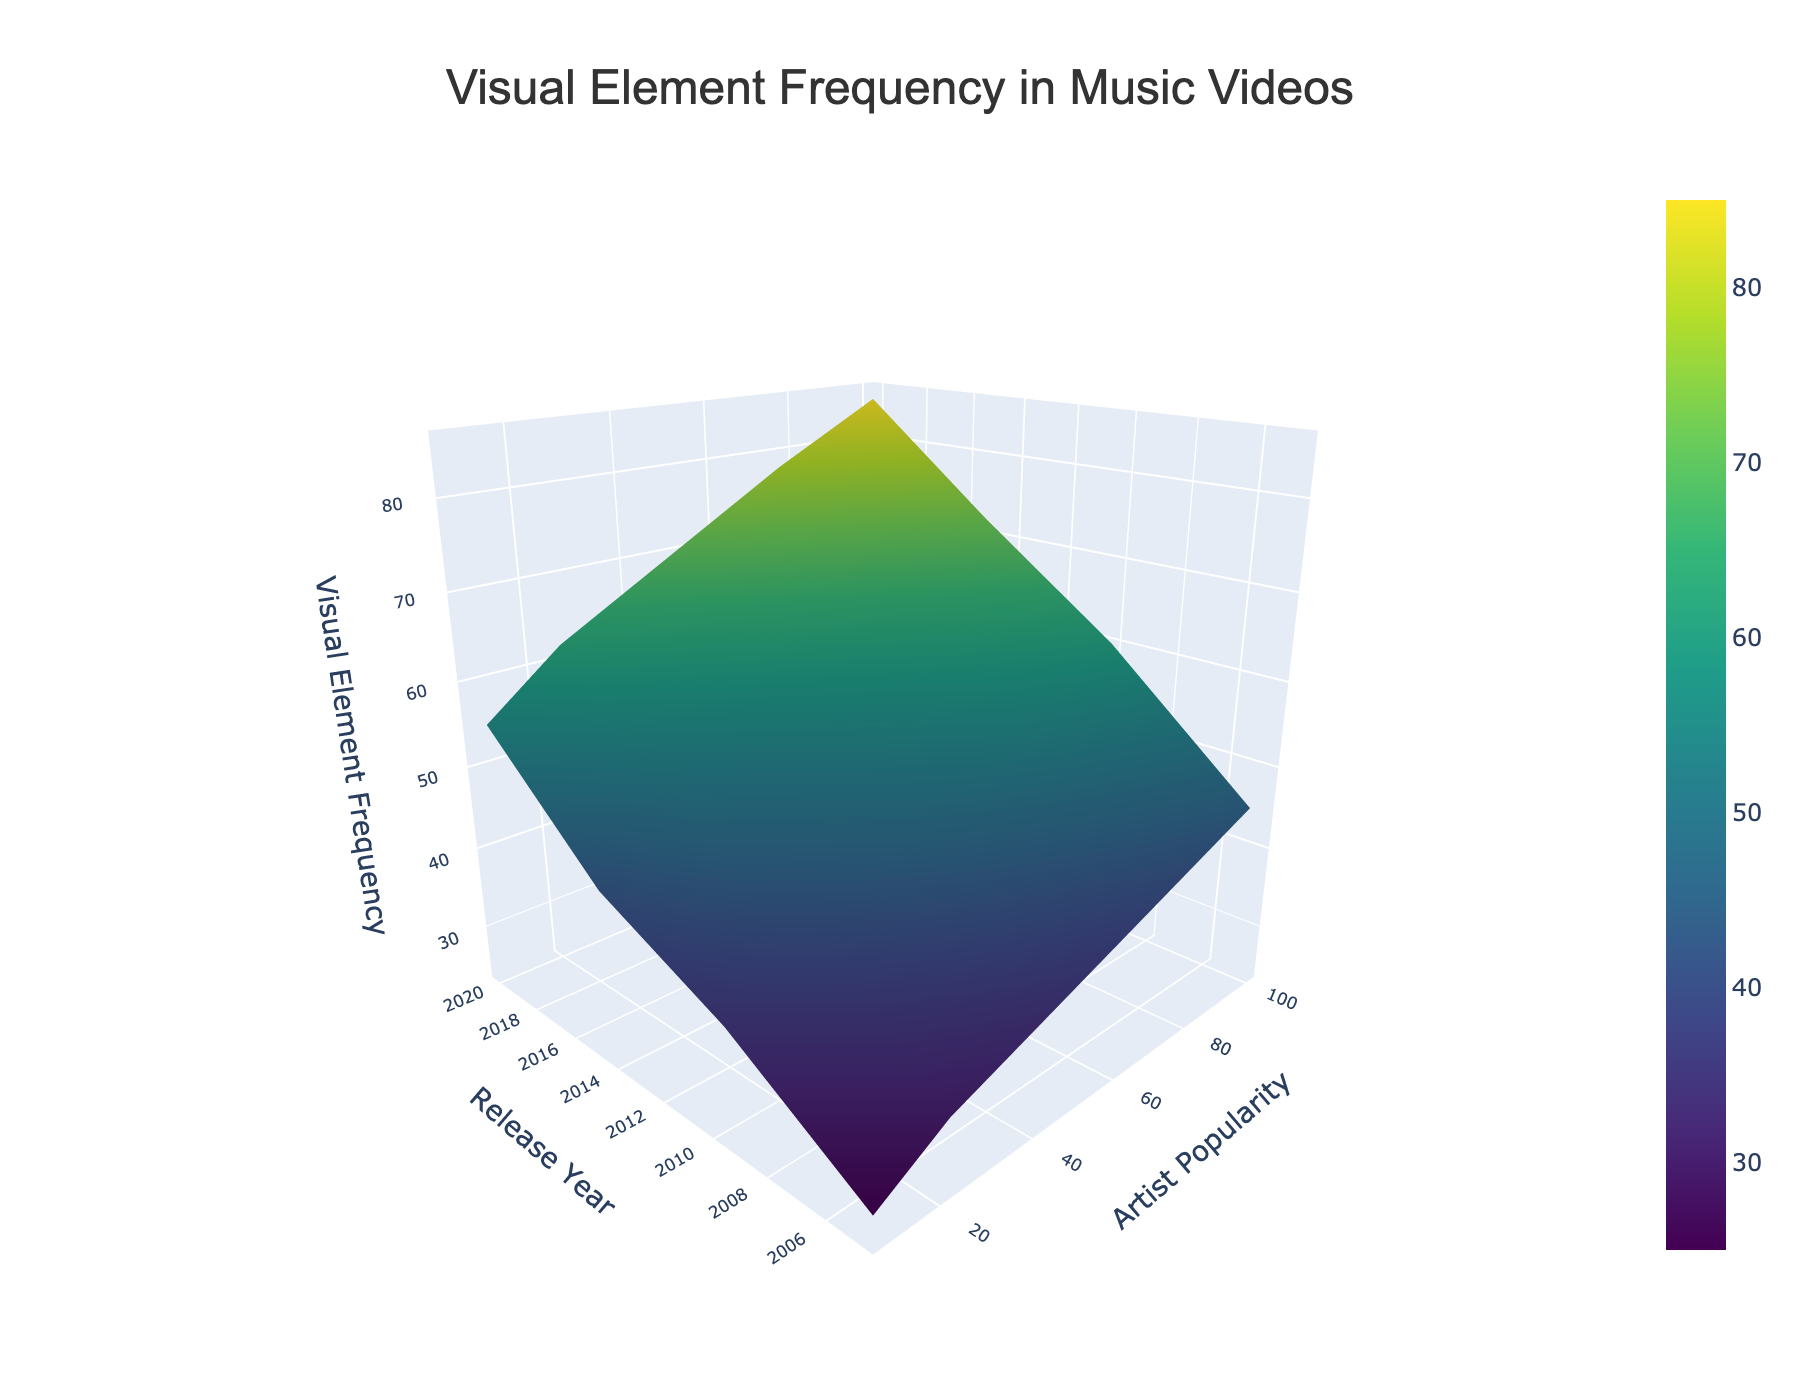What is the title of the figure? The title is located at the top of the figure; it's centered and usually in larger font size to stand out as the main descriptor.
Answer: Visual Element Frequency in Music Videos What does the z-axis represent in the plot? The z-axis, labeled on the figure, shows the type of data being measured or represented in the 3D surface plot. In this case, it indicates the frequency of visual elements in music videos.
Answer: Visual Element Frequency Which release year shows the highest visual element frequency for artists with high popularity (100)? Look at the 3D surface plot where the y-value is 100 (indicating high popularity). Find the highest peak along this line for different release years. The highest peak appears at the year 2020.
Answer: 2020 Compare the visual element frequency in 2010 and 2020 for artists with low popularity (10). Which year has higher frequency? Identify the points on the surface plot where the y-axis is 10 (low popularity) and compare the z-values (frequencies) for the years 2010 and 2020. The frequency is higher in 2020.
Answer: 2020 For artists with a popularity of 75, did the visual element frequency generally increase or decrease from 2005 to 2020? Observe the change in the visual element frequency for the popularity level of 75 over the years 2005 to 2020. The frequency shows an increasing trend.
Answer: Increase What's the visual element frequency for artists with a popularity of 50 in the year 2015? Find the point on the plot where the y-value is 50 and the x-value is 2015, then check the corresponding z-value to determine the frequency.
Answer: 58 Is there a consistent trend in the visual element frequency for all artists from 2005 to 2020? Analyze the plot to see if the visual element frequency generally increases, decreases, or stays the same over time for different popularity levels. The trend shows a general increase in frequency over time for most popularity levels.
Answer: Increase What's the average visual element frequency in 2020 across all popularity levels? Extract the z-values for the year 2020 across all popularity levels (10, 25, 50, 75, 100). Add these values and divide by the number of observations (5) to find the average. (85 + 78 + 70 + 62 + 55) / 5 = 70
Answer: 70 Which popularity level shows the lowest visual element frequency in 2005? Compare the z-values (frequencies) across different popularity levels for the year 2005, and find the lowest value. The lowest frequency in 2005 is for popularity level 10.
Answer: 10 What color scale is used in the 3D surface plot? The color scale used in the plot, which helps to visually differentiate the variations in the z-values, is mentioned in the code and visible in the plot itself. It is the Viridis color scale.
Answer: Viridis 